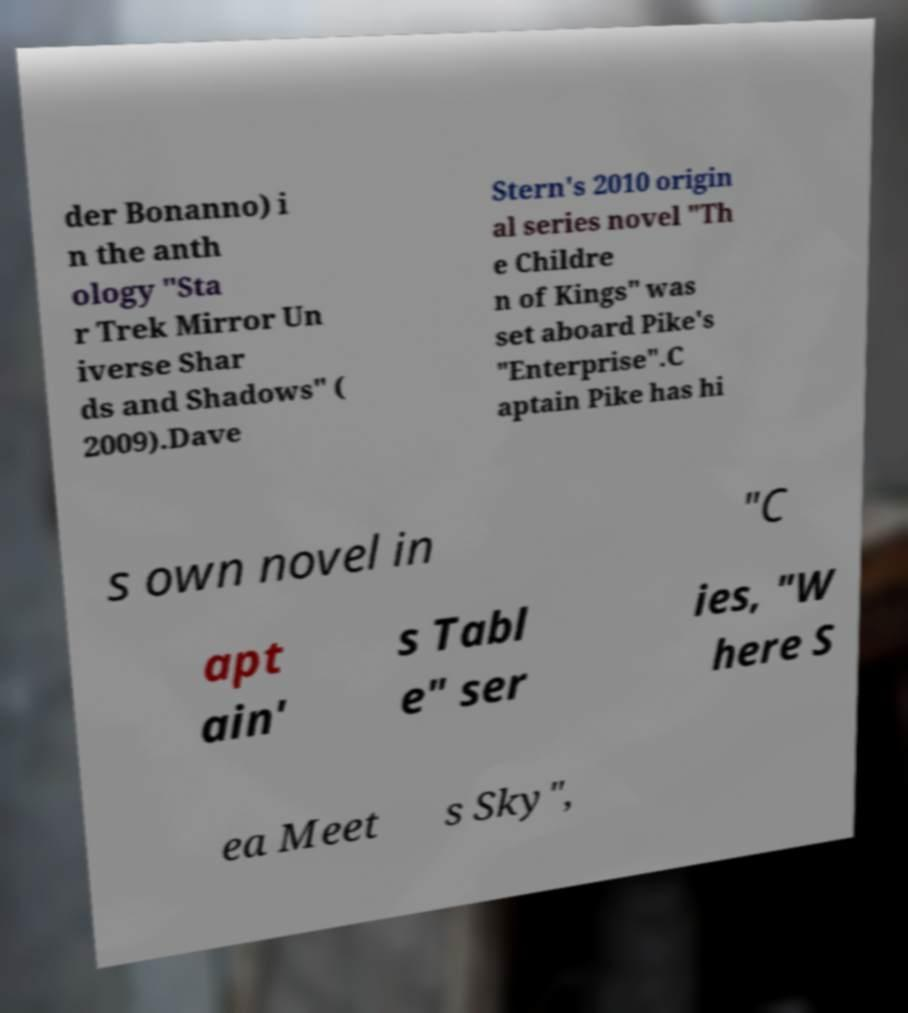Please read and relay the text visible in this image. What does it say? der Bonanno) i n the anth ology "Sta r Trek Mirror Un iverse Shar ds and Shadows" ( 2009).Dave Stern's 2010 origin al series novel "Th e Childre n of Kings" was set aboard Pike's "Enterprise".C aptain Pike has hi s own novel in "C apt ain' s Tabl e" ser ies, "W here S ea Meet s Sky", 